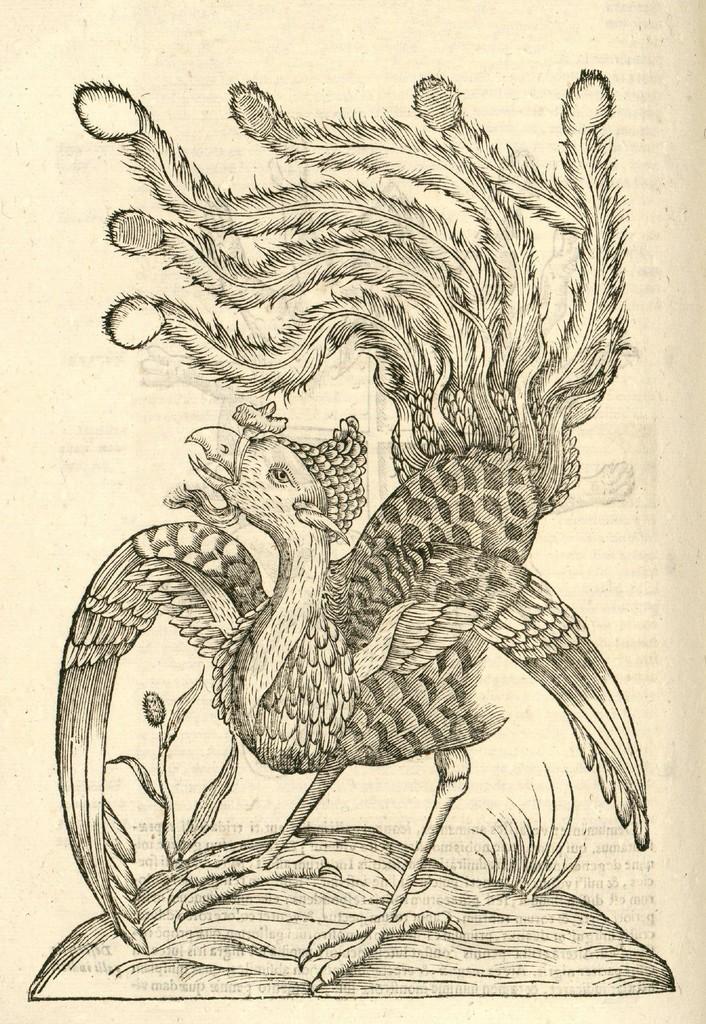Could you give a brief overview of what you see in this image? In this image I can see a sketch on a paper of a bird which is standing on a rock. I can see some grass on the rock. This sketch is on the cream colored paper. 